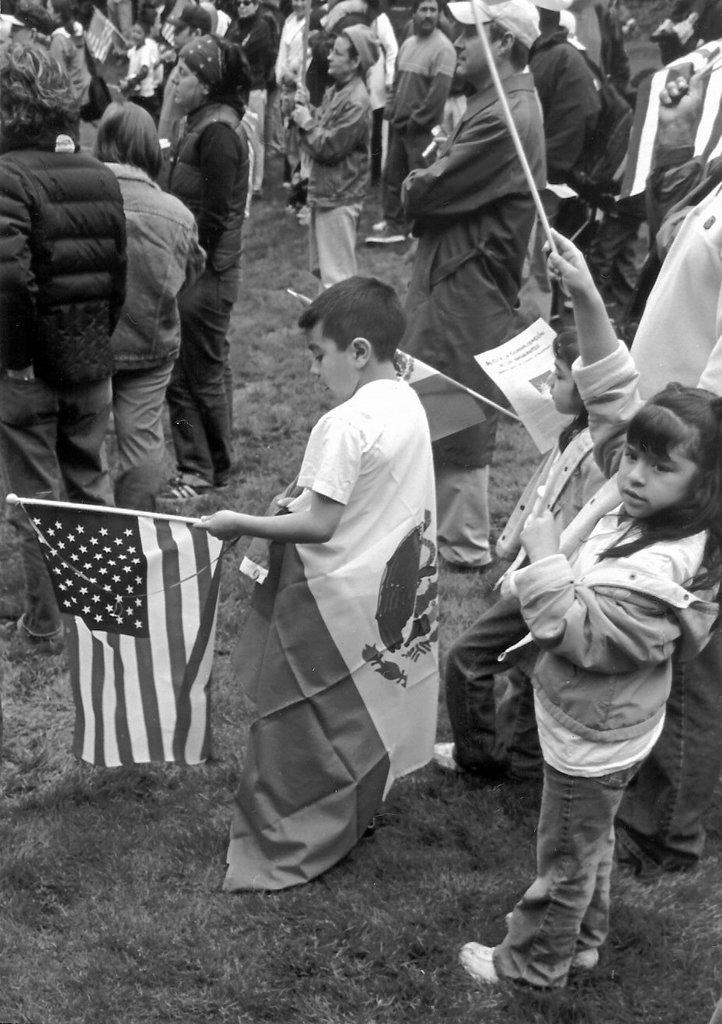What is the color scheme of the image? The image is black and white. What type of surface are the people standing on? The people are standing on the grass. What are some people holding in their hands? Some people are holding flags in their hands. What type of roof can be seen on the house in the image? There is no house or roof present in the image; it features people standing on the grass and holding flags. 